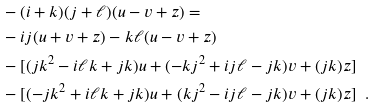Convert formula to latex. <formula><loc_0><loc_0><loc_500><loc_500>& - ( i + k ) ( j + \ell ) ( u - v + z ) = \\ & - i j ( u + v + z ) - k \ell ( u - v + z ) \\ & - [ ( j k ^ { 2 } - i \ell k + j k ) u + ( - k j ^ { 2 } + i j \ell - j k ) v + ( j k ) z ] \\ & - [ ( - j k ^ { 2 } + i \ell k + j k ) u + ( k j ^ { 2 } - i j \ell - j k ) v + ( j k ) z ] \ \ .</formula> 